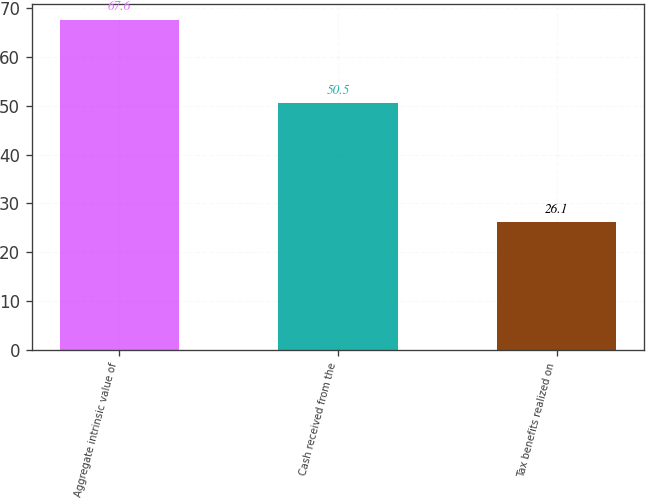<chart> <loc_0><loc_0><loc_500><loc_500><bar_chart><fcel>Aggregate intrinsic value of<fcel>Cash received from the<fcel>Tax benefits realized on<nl><fcel>67.6<fcel>50.5<fcel>26.1<nl></chart> 